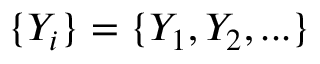Convert formula to latex. <formula><loc_0><loc_0><loc_500><loc_500>\{ Y _ { i } \} = \{ Y _ { 1 } , Y _ { 2 } , \dots \}</formula> 